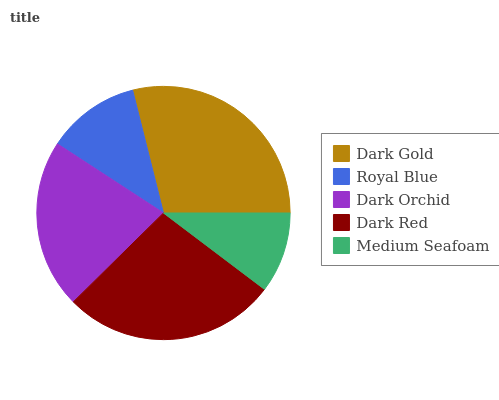Is Medium Seafoam the minimum?
Answer yes or no. Yes. Is Dark Gold the maximum?
Answer yes or no. Yes. Is Royal Blue the minimum?
Answer yes or no. No. Is Royal Blue the maximum?
Answer yes or no. No. Is Dark Gold greater than Royal Blue?
Answer yes or no. Yes. Is Royal Blue less than Dark Gold?
Answer yes or no. Yes. Is Royal Blue greater than Dark Gold?
Answer yes or no. No. Is Dark Gold less than Royal Blue?
Answer yes or no. No. Is Dark Orchid the high median?
Answer yes or no. Yes. Is Dark Orchid the low median?
Answer yes or no. Yes. Is Dark Gold the high median?
Answer yes or no. No. Is Dark Gold the low median?
Answer yes or no. No. 